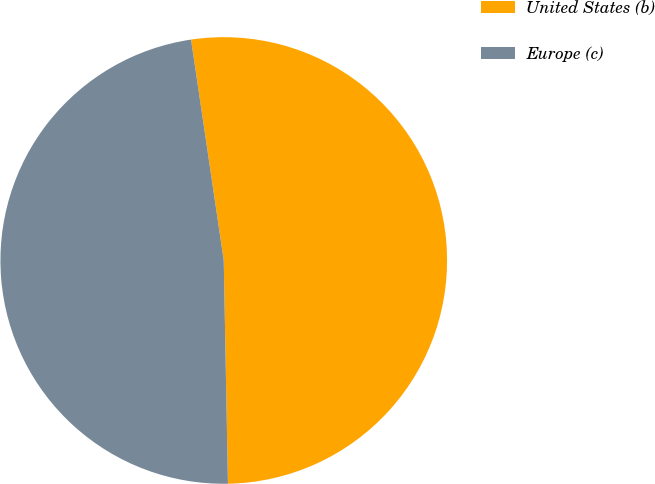Convert chart. <chart><loc_0><loc_0><loc_500><loc_500><pie_chart><fcel>United States (b)<fcel>Europe (c)<nl><fcel>52.04%<fcel>47.96%<nl></chart> 